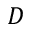Convert formula to latex. <formula><loc_0><loc_0><loc_500><loc_500>D</formula> 